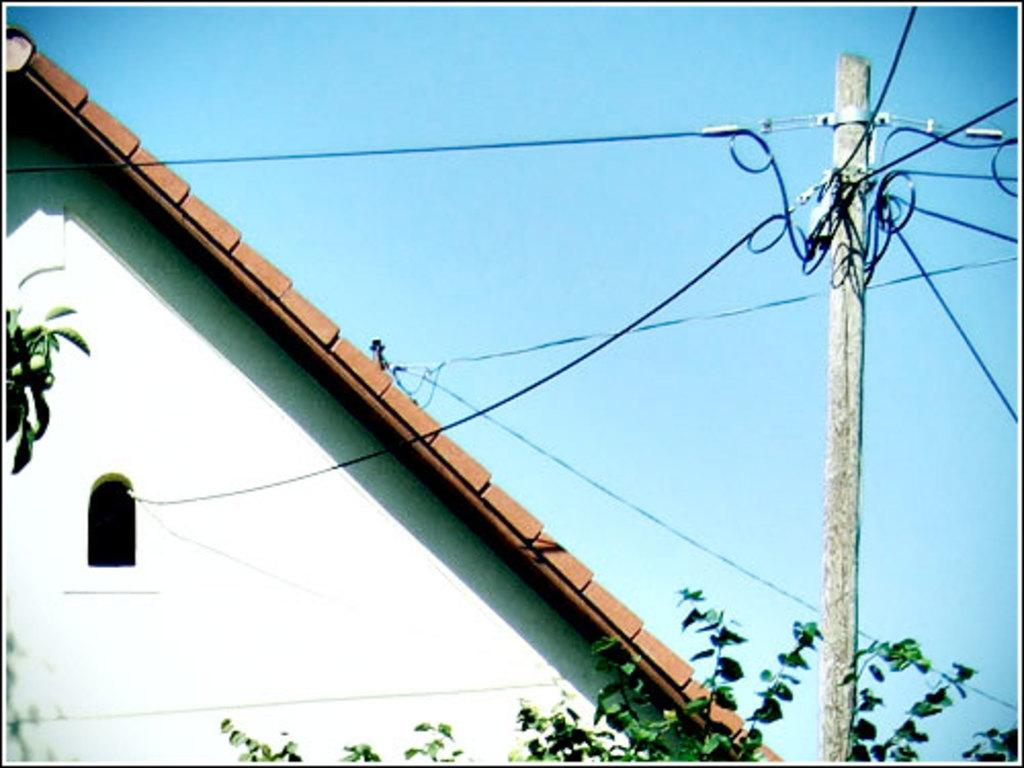What type of structure is visible in the image? There is a building with a window in the image. What can be seen in the foreground of the image? There is a plant and a pole with cables in the foreground of the image. What is visible in the background of the image? The sky is visible in the background of the image. Can you see a clam crawling on the plant in the image? There is no clam present in the image; it features a plant and a pole with cables in the foreground. What type of pen is being used to write on the building in the image? There is no pen or writing visible on the building in the image. 